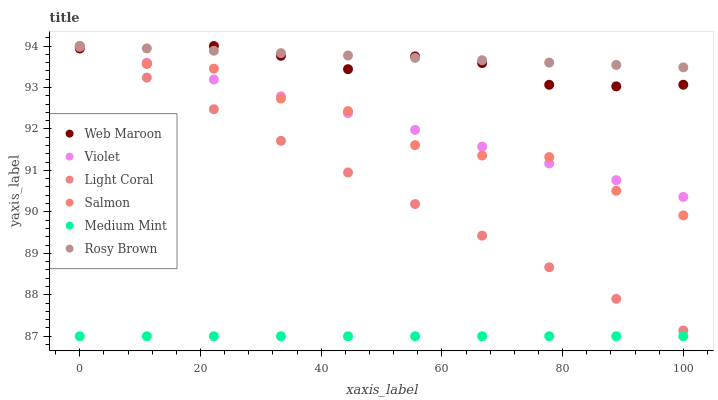Does Medium Mint have the minimum area under the curve?
Answer yes or no. Yes. Does Rosy Brown have the maximum area under the curve?
Answer yes or no. Yes. Does Web Maroon have the minimum area under the curve?
Answer yes or no. No. Does Web Maroon have the maximum area under the curve?
Answer yes or no. No. Is Medium Mint the smoothest?
Answer yes or no. Yes. Is Salmon the roughest?
Answer yes or no. Yes. Is Web Maroon the smoothest?
Answer yes or no. No. Is Web Maroon the roughest?
Answer yes or no. No. Does Medium Mint have the lowest value?
Answer yes or no. Yes. Does Web Maroon have the lowest value?
Answer yes or no. No. Does Violet have the highest value?
Answer yes or no. Yes. Does Salmon have the highest value?
Answer yes or no. No. Is Medium Mint less than Web Maroon?
Answer yes or no. Yes. Is Web Maroon greater than Medium Mint?
Answer yes or no. Yes. Does Salmon intersect Violet?
Answer yes or no. Yes. Is Salmon less than Violet?
Answer yes or no. No. Is Salmon greater than Violet?
Answer yes or no. No. Does Medium Mint intersect Web Maroon?
Answer yes or no. No. 